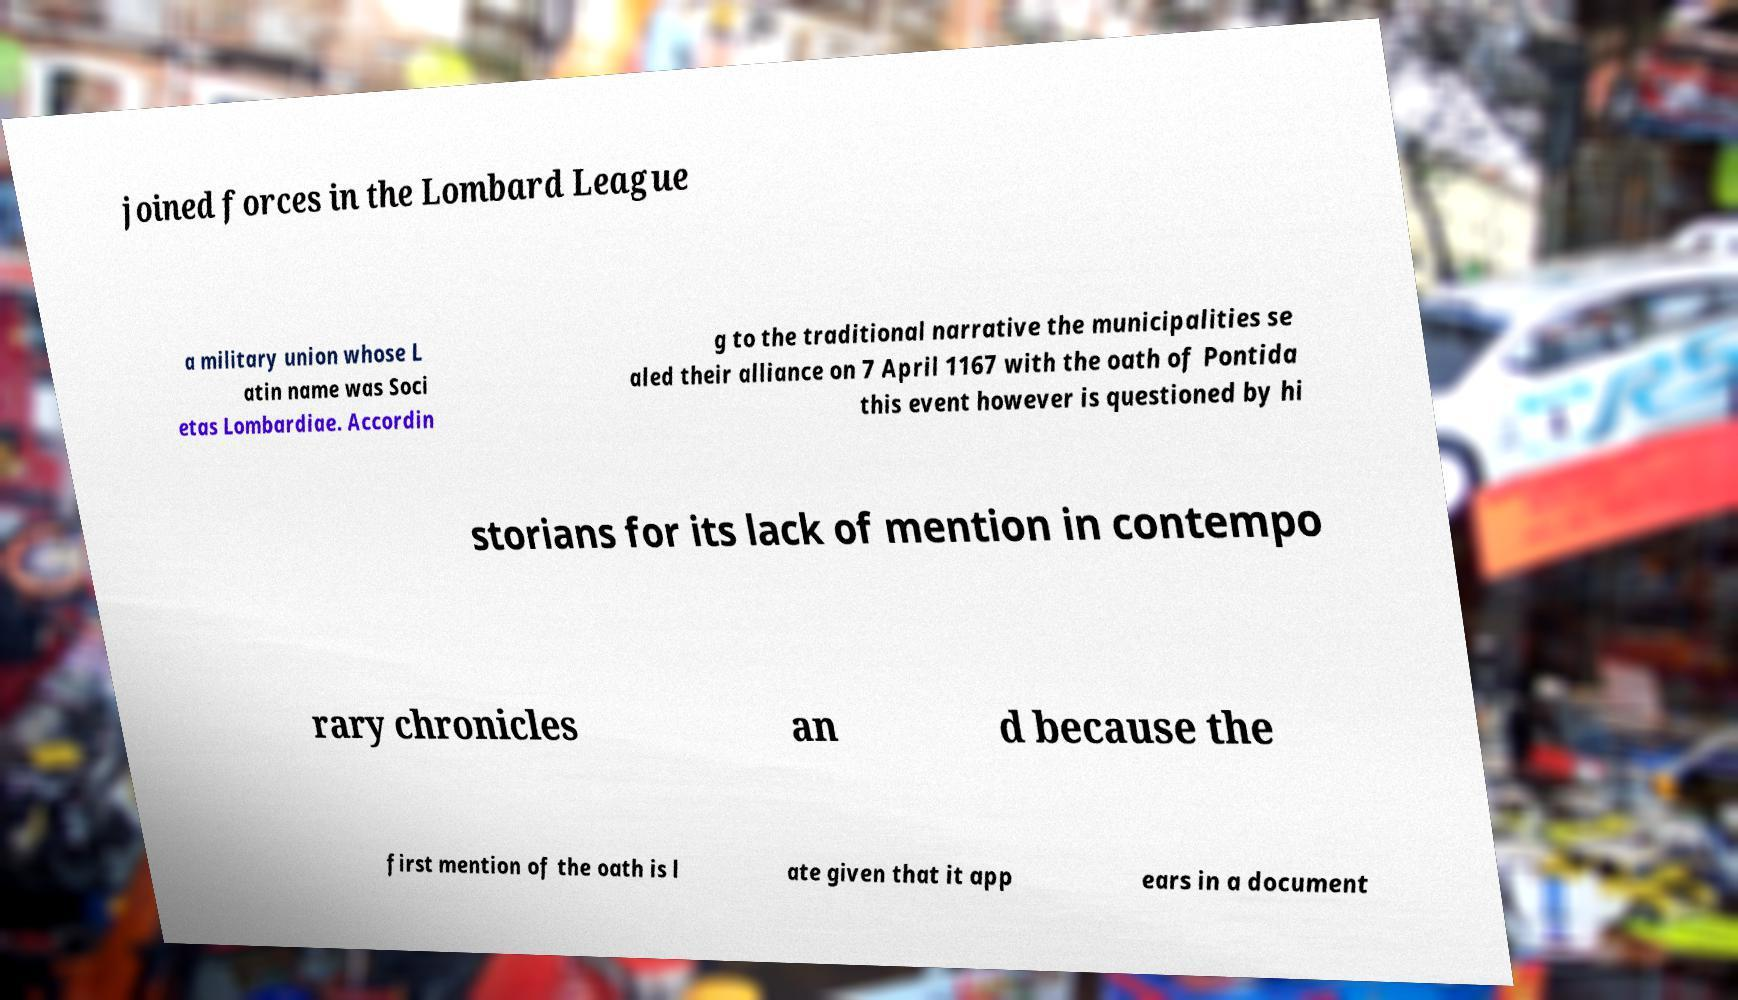Please read and relay the text visible in this image. What does it say? joined forces in the Lombard League a military union whose L atin name was Soci etas Lombardiae. Accordin g to the traditional narrative the municipalities se aled their alliance on 7 April 1167 with the oath of Pontida this event however is questioned by hi storians for its lack of mention in contempo rary chronicles an d because the first mention of the oath is l ate given that it app ears in a document 